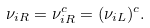<formula> <loc_0><loc_0><loc_500><loc_500>\nu _ { i R } = \nu ^ { c } _ { i R } = ( \nu _ { i L } ) ^ { c } .</formula> 